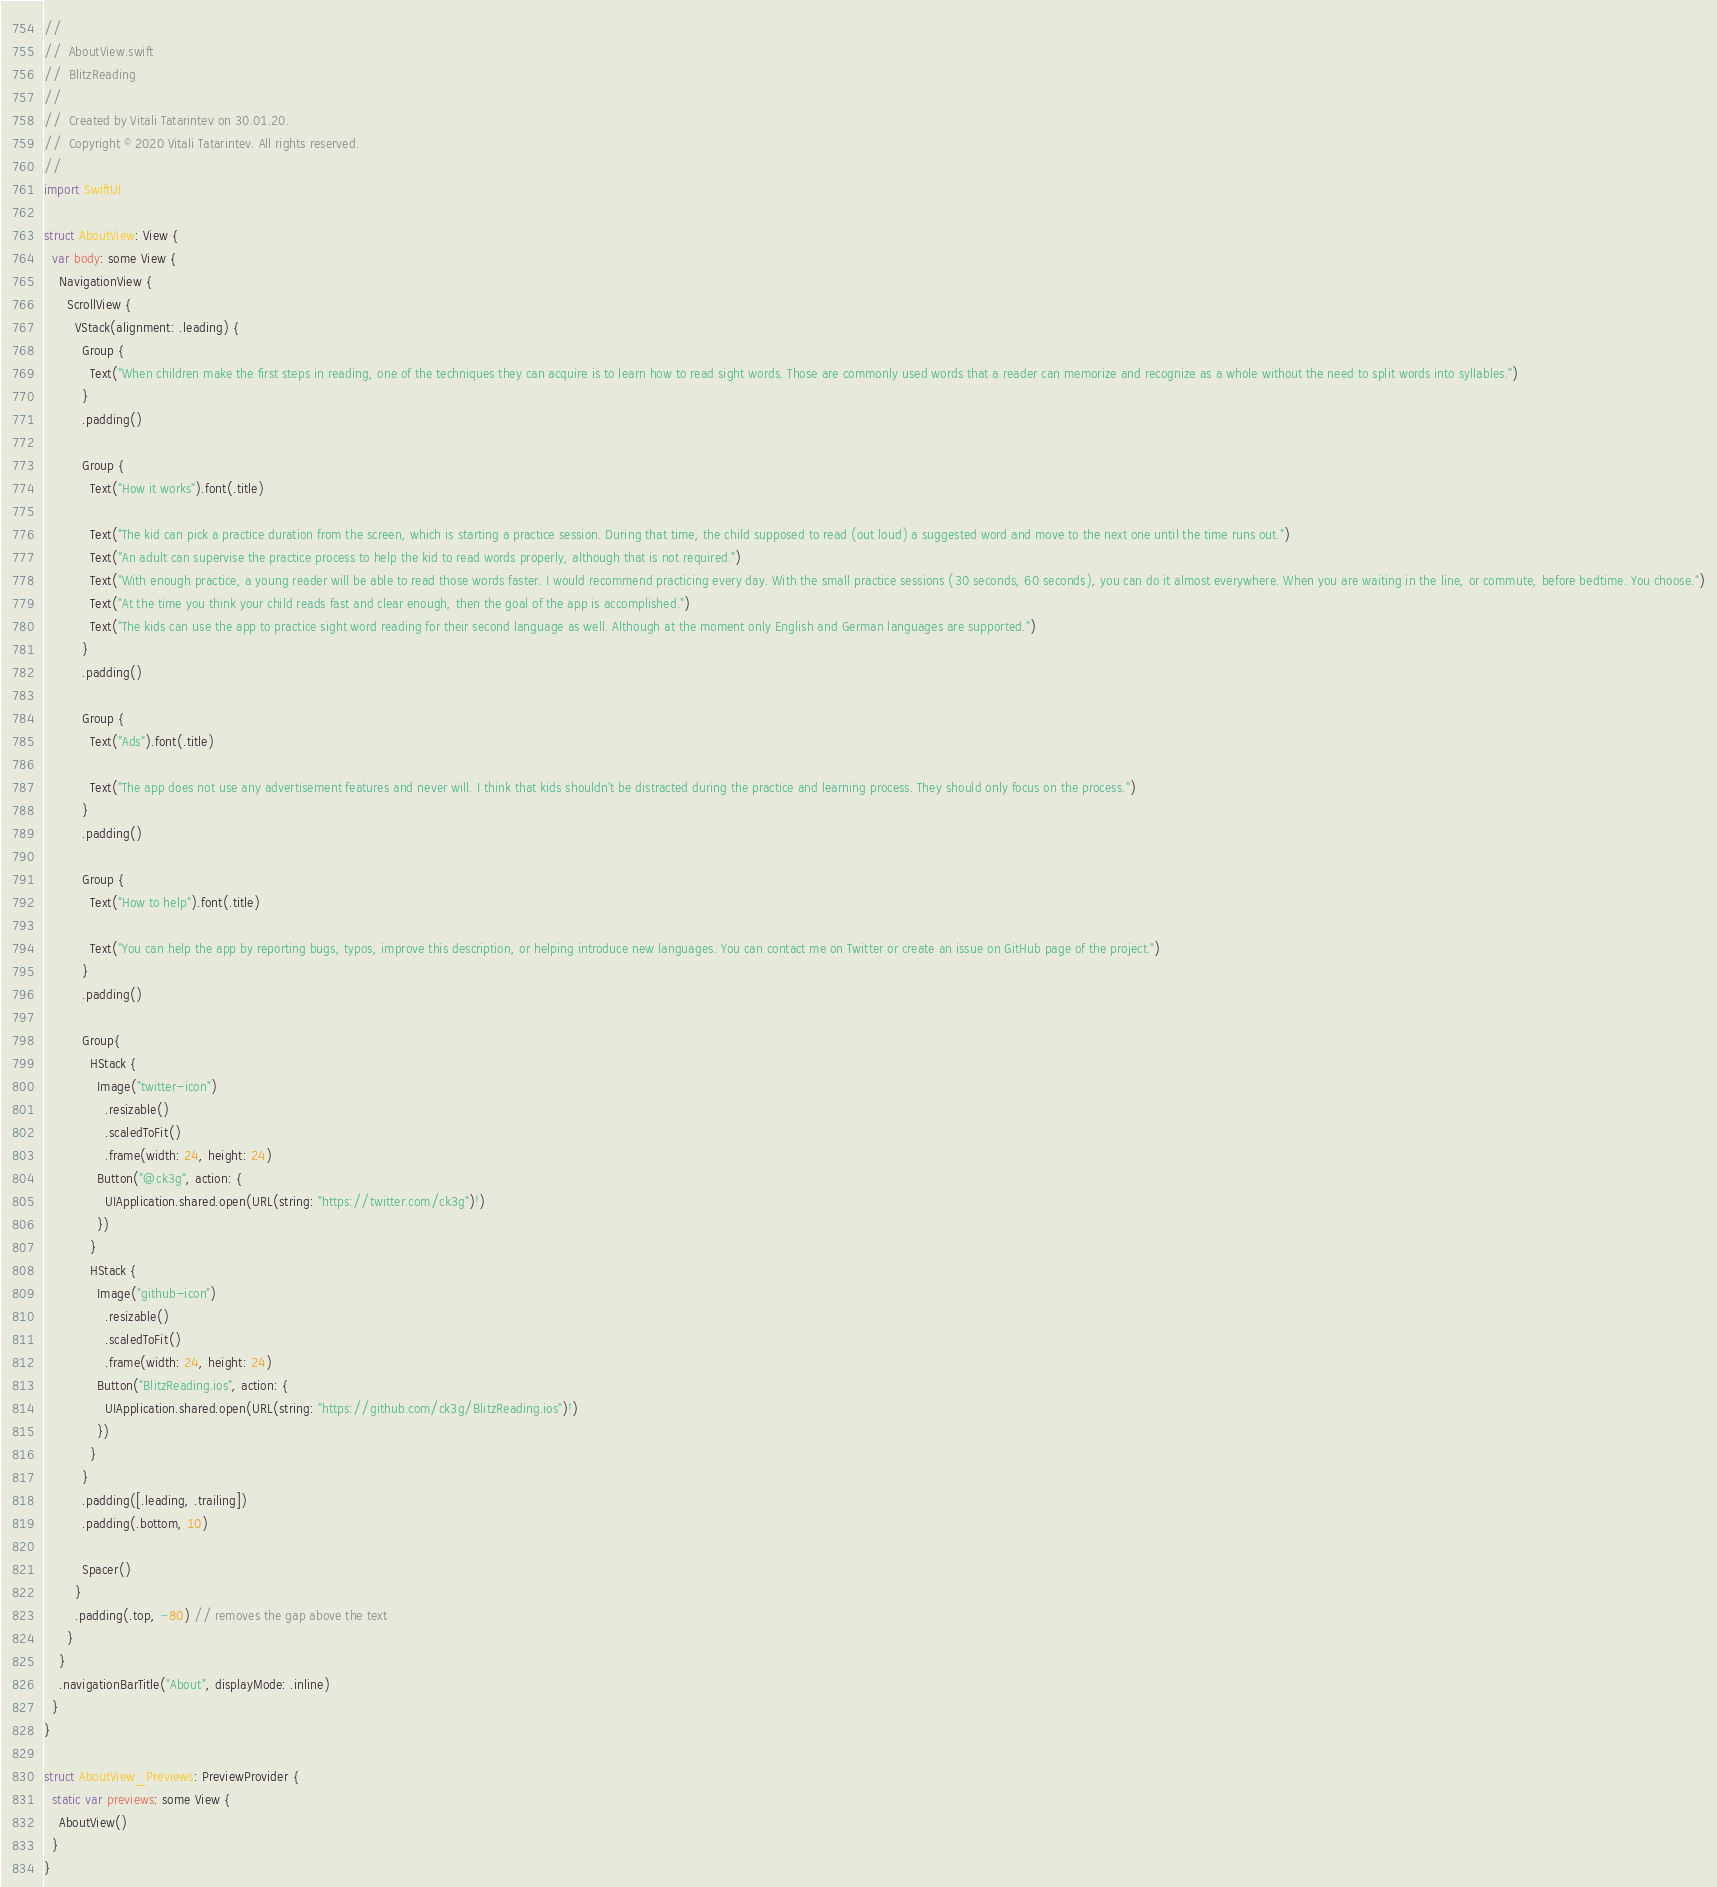Convert code to text. <code><loc_0><loc_0><loc_500><loc_500><_Swift_>//
//  AboutView.swift
//  BlitzReading
//
//  Created by Vitali Tatarintev on 30.01.20.
//  Copyright © 2020 Vitali Tatarintev. All rights reserved.
//
import SwiftUI

struct AboutView: View {
  var body: some View {
    NavigationView {
      ScrollView {
        VStack(alignment: .leading) {
          Group {
            Text("When children make the first steps in reading, one of the techniques they can acquire is to learn how to read sight words. Those are commonly used words that a reader can memorize and recognize as a whole without the need to split words into syllables.")
          }
          .padding()

          Group {
            Text("How it works").font(.title)

            Text("The kid can pick a practice duration from the screen, which is starting a practice session. During that time, the child supposed to read (out loud) a suggested word and move to the next one until the time runs out.")
            Text("An adult can supervise the practice process to help the kid to read words properly, although that is not required.")
            Text("With enough practice, a young reader will be able to read those words faster. I would recommend practicing every day. With the small practice sessions (30 seconds, 60 seconds), you can do it almost everywhere. When you are waiting in the line, or commute, before bedtime. You choose.")
            Text("At the time you think your child reads fast and clear enough, then the goal of the app is accomplished.")
            Text("The kids can use the app to practice sight word reading for their second language as well. Although at the moment only English and German languages are supported.")
          }
          .padding()

          Group {
            Text("Ads").font(.title)

            Text("The app does not use any advertisement features and never will. I think that kids shouldn't be distracted during the practice and learning process. They should only focus on the process.")
          }
          .padding()

          Group {
            Text("How to help").font(.title)

            Text("You can help the app by reporting bugs, typos, improve this description, or helping introduce new languages. You can contact me on Twitter or create an issue on GitHub page of the project.")
          }
          .padding()

          Group{
            HStack {
              Image("twitter-icon")
                .resizable()
                .scaledToFit()
                .frame(width: 24, height: 24)
              Button("@ck3g", action: {
                UIApplication.shared.open(URL(string: "https://twitter.com/ck3g")!)
              })
            }
            HStack {
              Image("github-icon")
                .resizable()
                .scaledToFit()
                .frame(width: 24, height: 24)
              Button("BlitzReading.ios", action: {
                UIApplication.shared.open(URL(string: "https://github.com/ck3g/BlitzReading.ios")!)
              })
            }
          }
          .padding([.leading, .trailing])
          .padding(.bottom, 10)

          Spacer()
        }
        .padding(.top, -80) // removes the gap above the text
      }
    }
    .navigationBarTitle("About", displayMode: .inline)
  }
}

struct AboutView_Previews: PreviewProvider {
  static var previews: some View {
    AboutView()
  }
}
</code> 